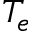<formula> <loc_0><loc_0><loc_500><loc_500>T _ { e }</formula> 